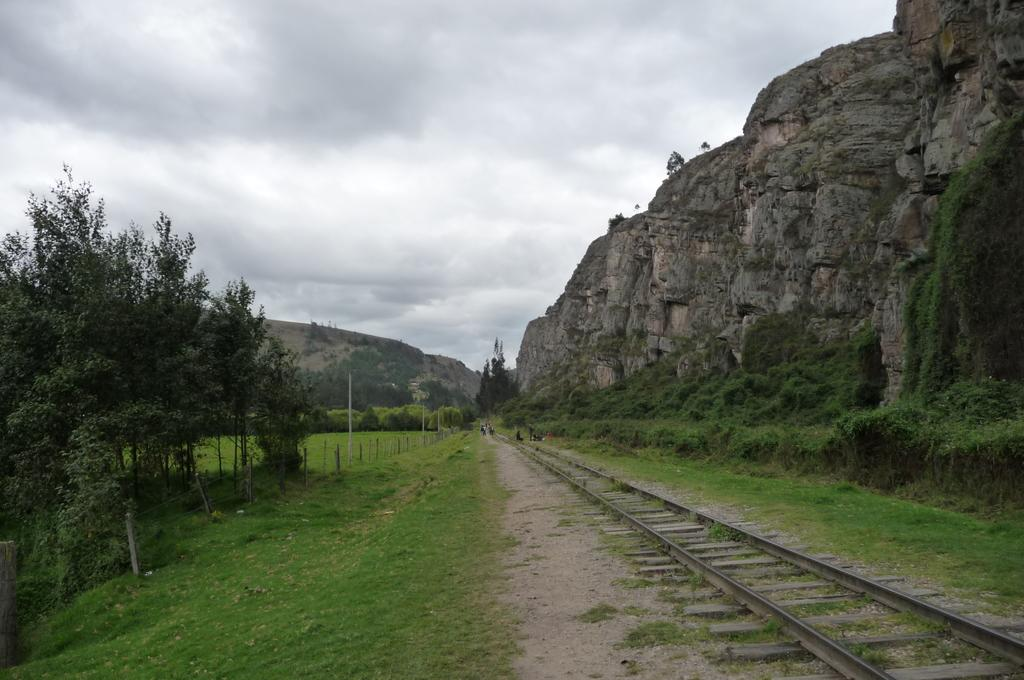What is the main feature in the image? There is a track in the image. Where is the track located in relation to other features? The track is beside a hill. What type of vegetation can be seen on the left side of the image? There are trees on the left side of the image. What is visible at the top of the image? The sky is visible at the top of the image. What type of vein is visible on the track in the image? There are no veins visible on the track in the image; it is a physical structure for vehicles or people to travel on. 